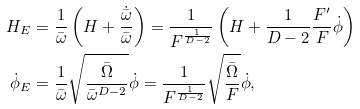Convert formula to latex. <formula><loc_0><loc_0><loc_500><loc_500>H _ { E } & = \frac { 1 } { \bar { \omega } } \left ( H + \frac { \dot { \bar { \omega } } } { \bar { \omega } } \right ) = \frac { 1 } { F ^ { \frac { 1 } { D - 2 } } } \left ( H + \frac { 1 } { D - 2 } \frac { F ^ { \prime } } { F } \dot { \phi } \right ) \\ \dot { \phi } _ { E } & = \frac { 1 } { \bar { \omega } } \sqrt { \frac { \bar { \Omega } } { \bar { \omega } ^ { D - 2 } } } \dot { \phi } = \frac { 1 } { F ^ { \frac { 1 } { D - 2 } } } \sqrt { \frac { \bar { \Omega } } { F } } \dot { \phi } ,</formula> 